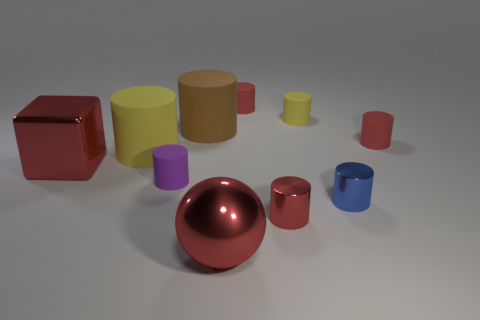How many blue objects are either shiny cylinders or big things?
Offer a very short reply. 1. There is a metal thing that is both behind the big sphere and in front of the small blue thing; what is its color?
Your answer should be compact. Red. How many tiny things are yellow rubber balls or blue cylinders?
Give a very brief answer. 1. The brown thing that is the same shape as the tiny yellow object is what size?
Keep it short and to the point. Large. The brown object is what shape?
Offer a terse response. Cylinder. Are the large ball and the big red object that is behind the small red metal cylinder made of the same material?
Your answer should be compact. Yes. How many metallic things are small red things or large yellow cylinders?
Keep it short and to the point. 1. What is the size of the yellow rubber cylinder that is behind the big brown thing?
Provide a short and direct response. Small. There is a ball that is made of the same material as the red block; what size is it?
Your response must be concise. Large. What number of matte things have the same color as the cube?
Give a very brief answer. 2. 